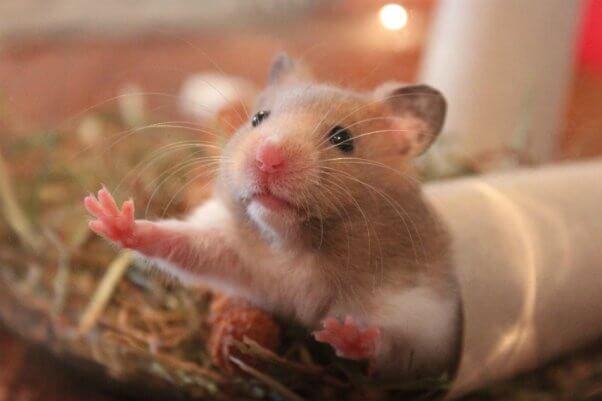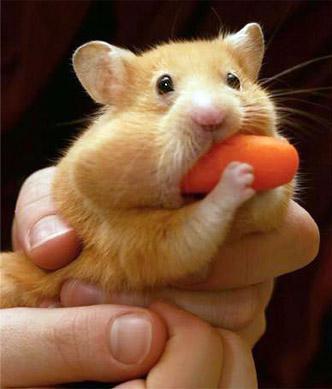The first image is the image on the left, the second image is the image on the right. For the images shown, is this caption "There is a hamster eating a carrot." true? Answer yes or no. Yes. 